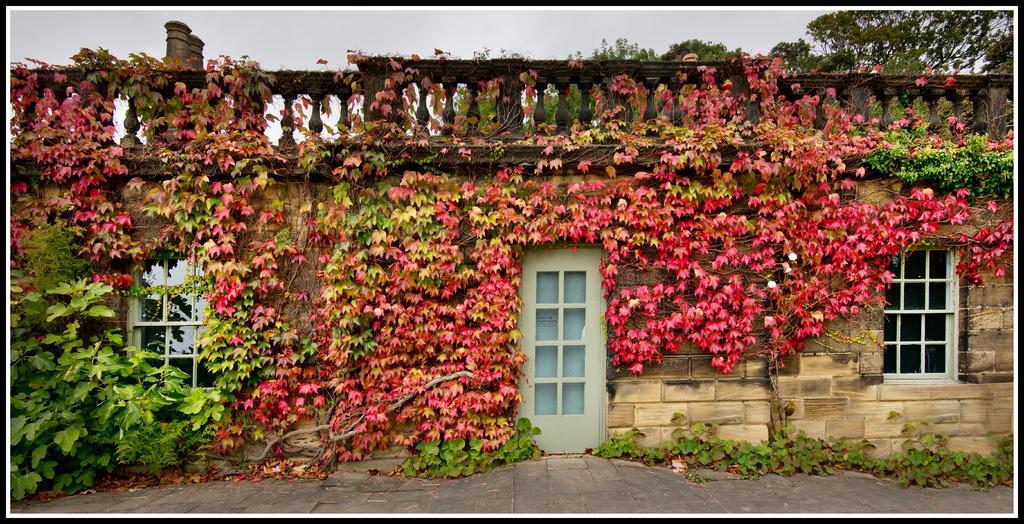Describe this image in one or two sentences. In this image there is a house. There are doors and windows to the walls of the house. There are plants on the walls of the house. At the top there is the sky. At the bottom there is the ground. 